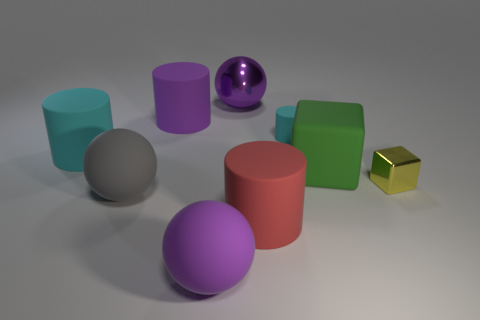Add 1 small green rubber cubes. How many objects exist? 10 Subtract all big matte balls. How many balls are left? 1 Subtract all purple balls. How many balls are left? 1 Subtract all cylinders. How many objects are left? 5 Subtract 1 cubes. How many cubes are left? 1 Add 3 tiny blocks. How many tiny blocks exist? 4 Subtract 1 cyan cylinders. How many objects are left? 8 Subtract all yellow blocks. Subtract all red spheres. How many blocks are left? 1 Subtract all gray blocks. How many blue cylinders are left? 0 Subtract all tiny cyan shiny cylinders. Subtract all green matte objects. How many objects are left? 8 